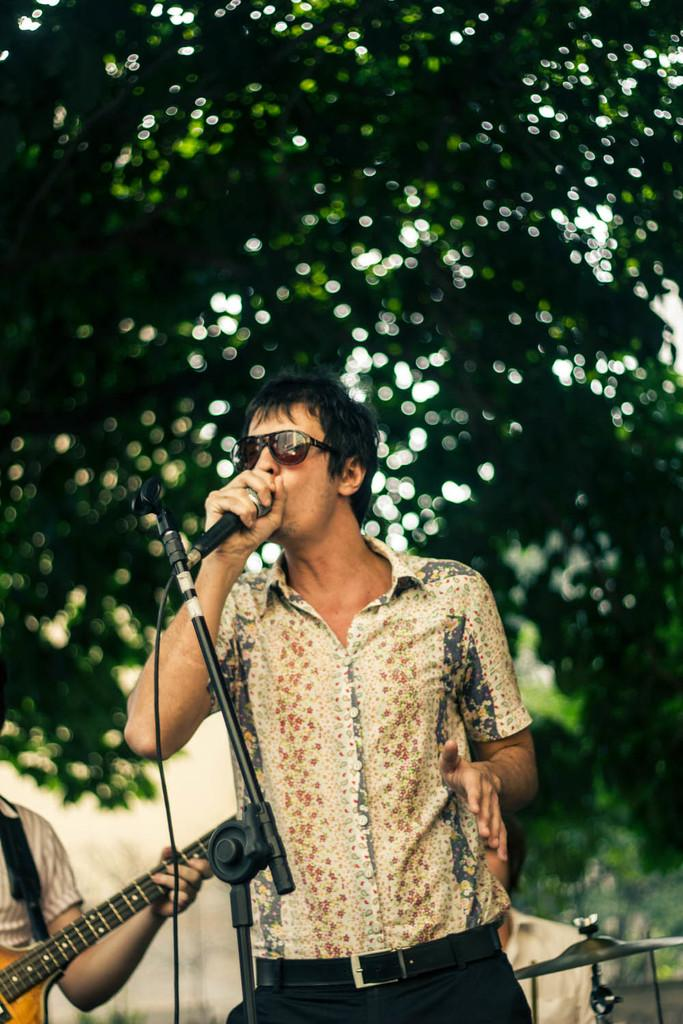What is the man in the image doing? The man is singing in the image. What object is the man holding while singing? The man is holding a microphone. Are there any other musicians in the image? Yes, there is a person playing guitar in the image. What can be seen in the background of the image? Trees are visible in the background of the image. What type of brass instrument is being played by the man in the image? There is no brass instrument being played in the image; the man is singing and holding a microphone, and there is a person playing guitar. 